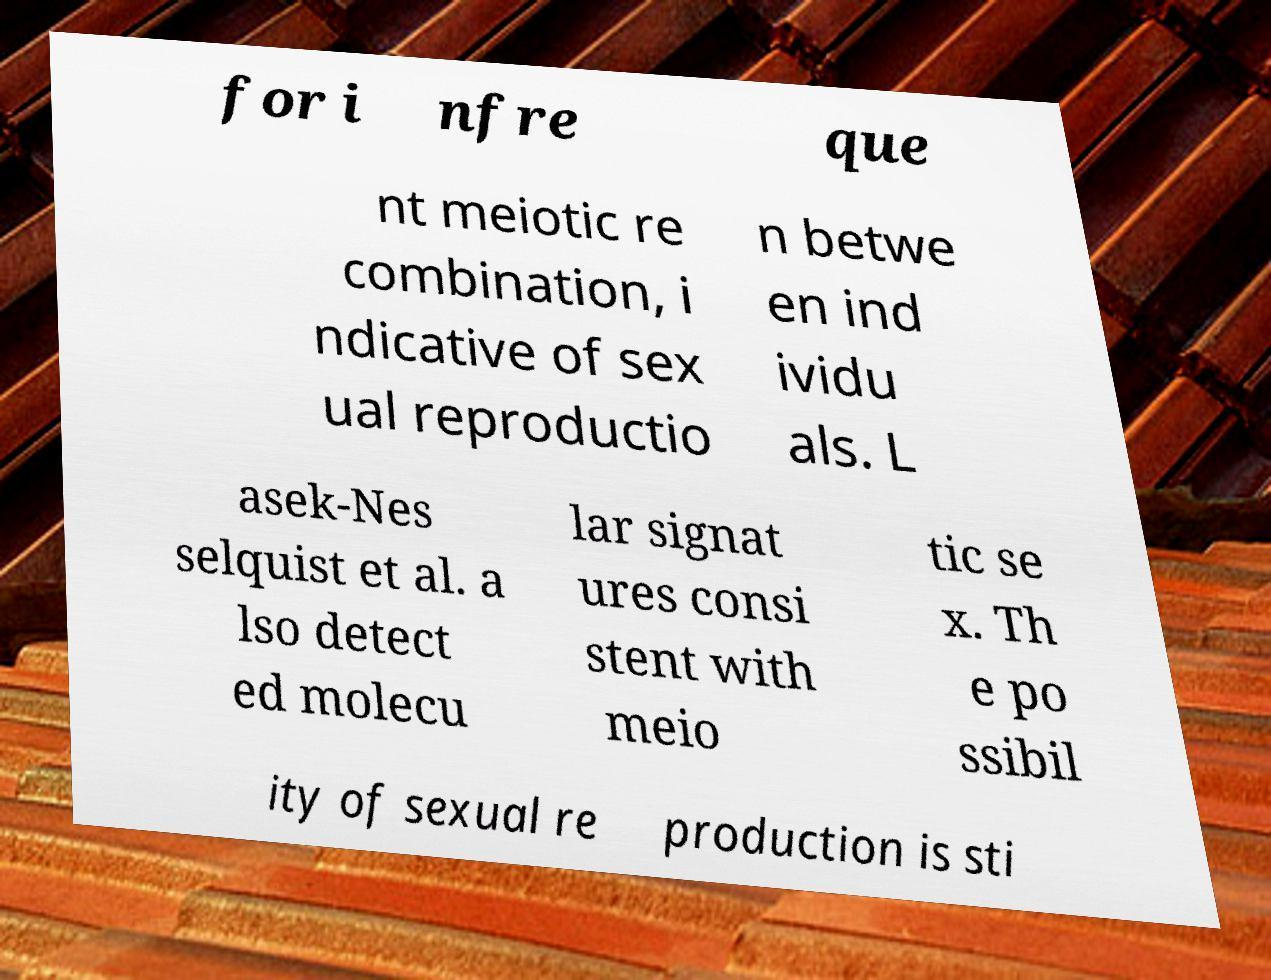Could you assist in decoding the text presented in this image and type it out clearly? for i nfre que nt meiotic re combination, i ndicative of sex ual reproductio n betwe en ind ividu als. L asek-Nes selquist et al. a lso detect ed molecu lar signat ures consi stent with meio tic se x. Th e po ssibil ity of sexual re production is sti 